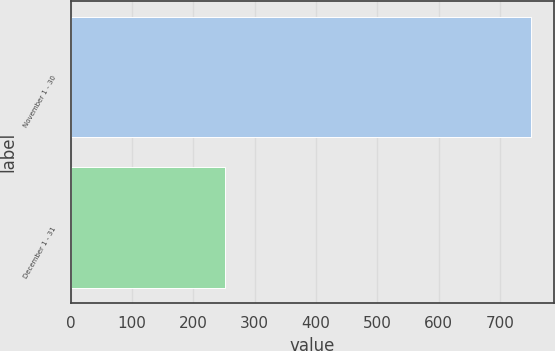Convert chart to OTSL. <chart><loc_0><loc_0><loc_500><loc_500><bar_chart><fcel>November 1 - 30<fcel>December 1 - 31<nl><fcel>750<fcel>251<nl></chart> 